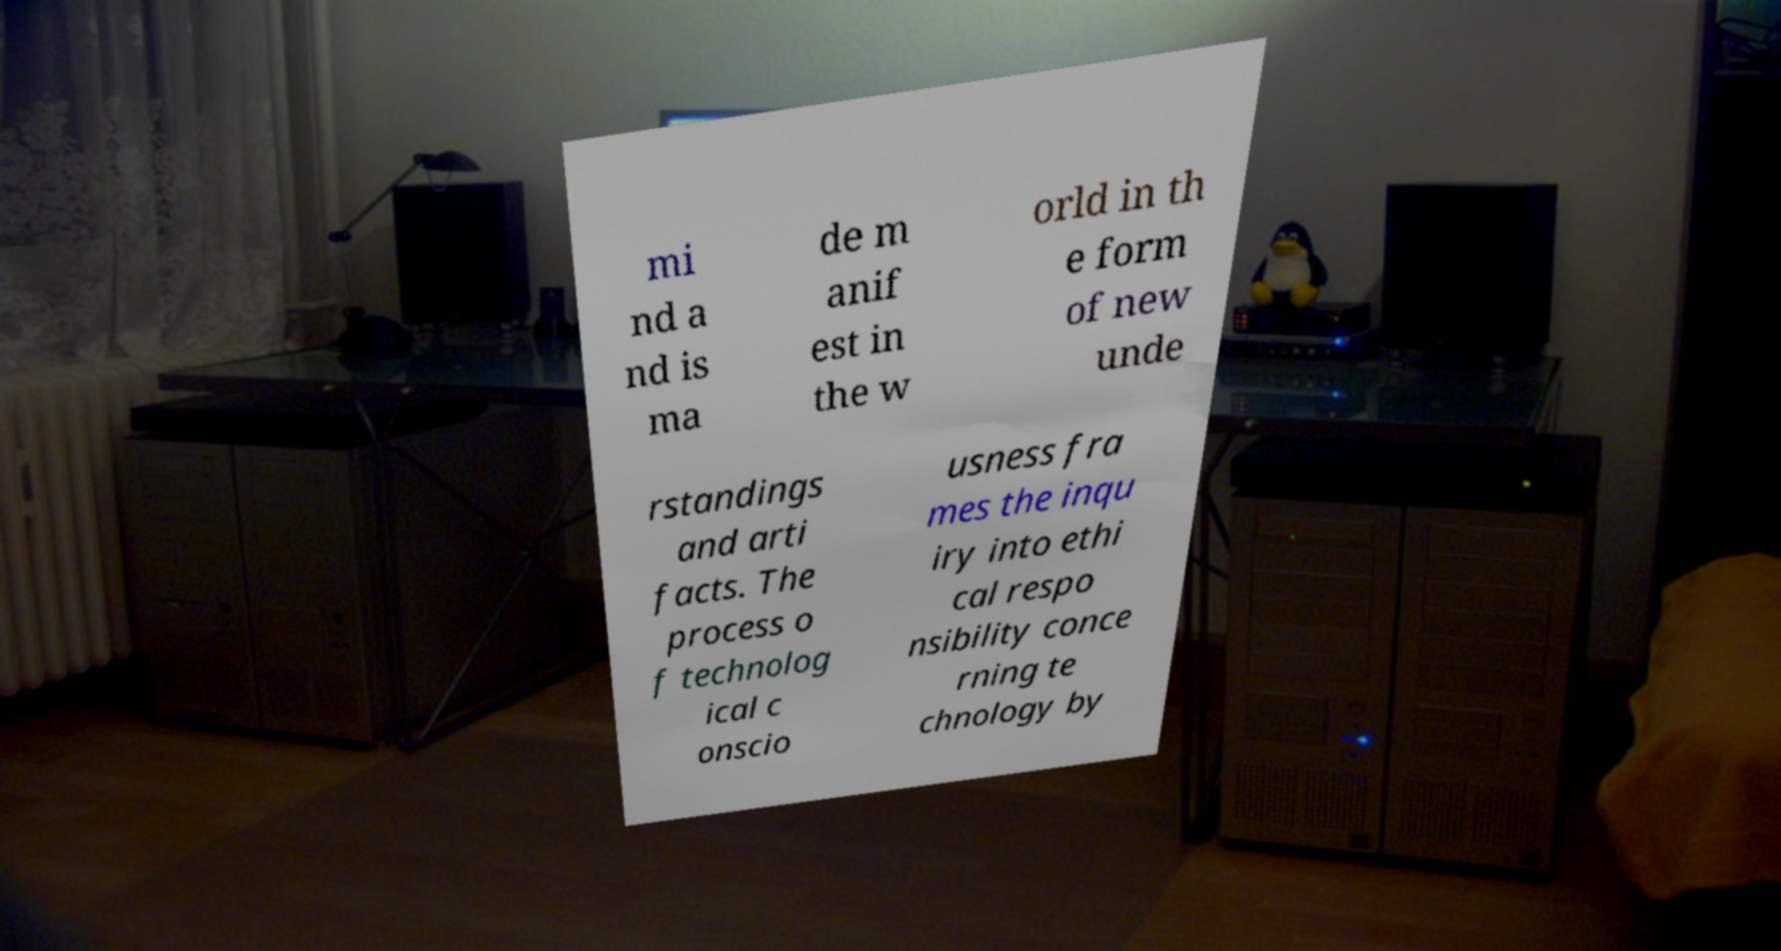Can you accurately transcribe the text from the provided image for me? mi nd a nd is ma de m anif est in the w orld in th e form of new unde rstandings and arti facts. The process o f technolog ical c onscio usness fra mes the inqu iry into ethi cal respo nsibility conce rning te chnology by 